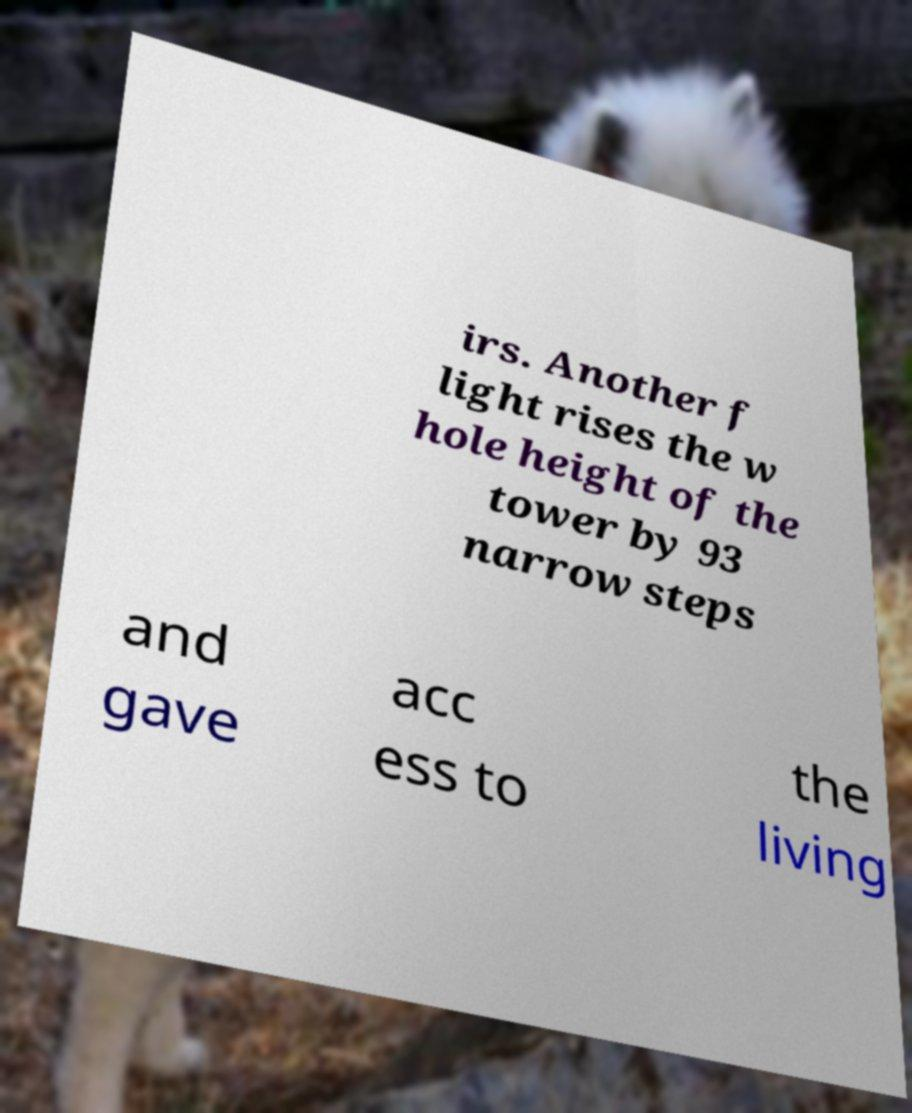Could you assist in decoding the text presented in this image and type it out clearly? irs. Another f light rises the w hole height of the tower by 93 narrow steps and gave acc ess to the living 